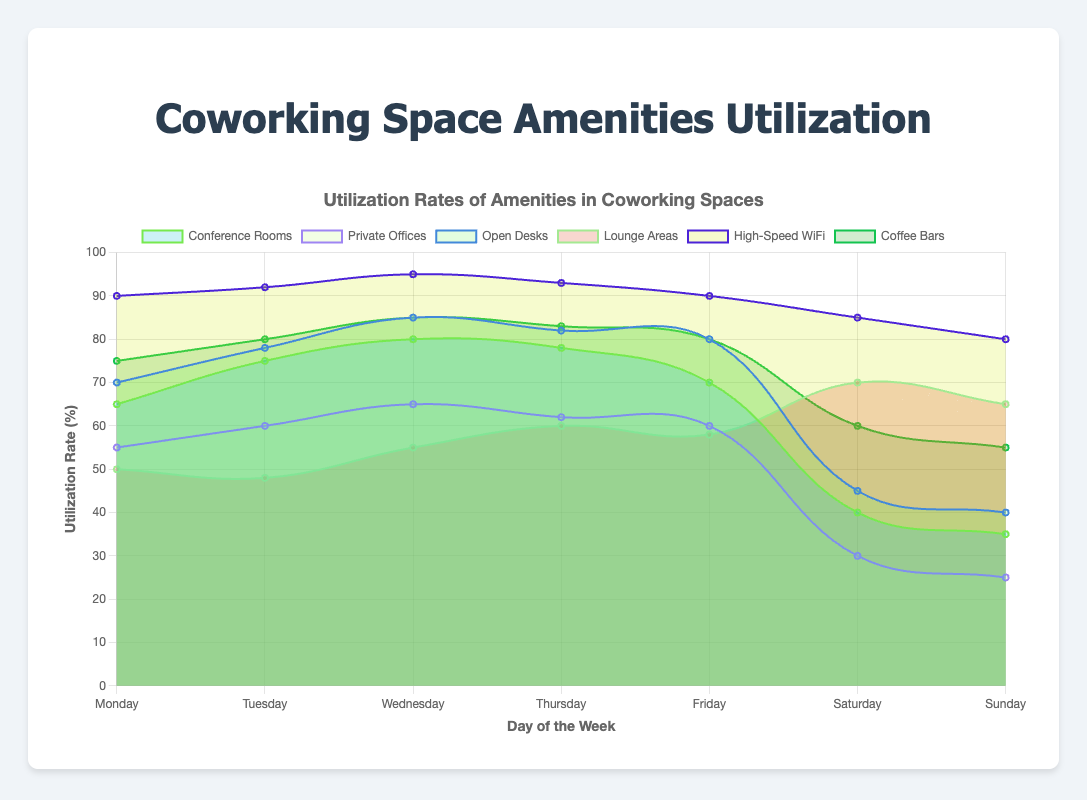What is the title of the chart? The title is usually displayed prominently at the top of the chart to provide a summary of what the chart is about.
Answer: Utilization Rates of Amenities in Coworking Spaces Which amenity has the highest utilization rate on Monday? Look at the utilization rates for each amenity on the Monday section of the x-axis and identify which one is the highest.
Answer: High-Speed WiFi On which day are Coffee Bars utilized the most? Examine the utilization rates of Coffee Bars across all days of the week, from Monday to Sunday, and identify the day with the highest value.
Answer: Wednesday Which two amenities have the closest utilization rates on Thursday? Compare the utilization rates for each amenity on Thursday and find the two that have the most similar numbers.
Answer: Private Offices and Lounge Areas What is the average utilization rate of Conference Rooms from Monday to Friday? Sum the utilization rates of Conference Rooms from Monday to Friday and divide by 5 to find the average. (65 + 75 + 80 + 78 + 70) / 5 = 368 / 5 = 73.6
Answer: 73.6 How does Saturday's utilization rate for Open Desks compare to Sunday’s? Look at the points for Open Desks on Saturday and Sunday and compare their values.
Answer: Saturday's utilization is higher than Sunday's What trend can be observed in the utilization rates of Lounge Areas from Monday to Sunday? Analyze the pattern of data points for Lounge Areas from Monday to Sunday to identify if there is an increasing, decreasing, or other pattern.
Answer: It increases from Monday to Sunday Which amenity shows the most significant drop in utilization rate from Friday to Saturday? Examine the utilization rates of all amenities from Friday to Saturday and find which one has the largest decrease.
Answer: Conference Rooms Between which two days does the utilization rate of High-Speed WiFi remain the highest without any decline? Look for a pair of consecutive days where the utilization rate of High-Speed WiFi remains high and does not drop.
Answer: Tuesday and Wednesday Rank the amenities based on their average utilization over the entire week. Calculate the average utilization for each amenity over the seven days and rank them from highest to lowest:
Conference Rooms: (65+75+80+78+70+40+35)/7 = 63.29
Private Offices: (55+60+65+62+60+30+25)/7 = 50.71
Open Desks: (70+78+85+82+80+45+40)/7 = 68.57
Lounge Areas: (50+48+55+60+58+70+65)/7 = 57.43
High-Speed WiFi: (90+92+95+93+90+85+80)/7 = 89.29
Coffee Bars: (75+80+85+83+80+60+55)/7 = 74
Answer: High-Speed WiFi, Coffee Bars, Open Desks, Conference Rooms, Lounge Areas, Private Offices
Answer: High-Speed WiFi, Coffee Bars, Open Desks, Conference Rooms, Lounge Areas, Private Offices 